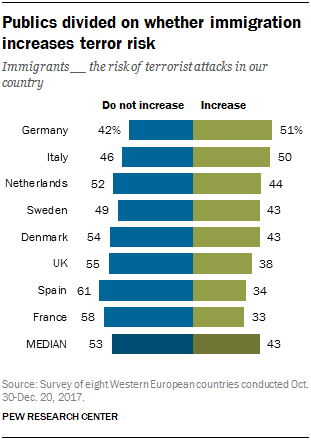Highlight a few significant elements in this photo. The maximum increase in the number of countries for the option 'How many countries increase' is greater than the number of countries for the option 'Do not increase'. 